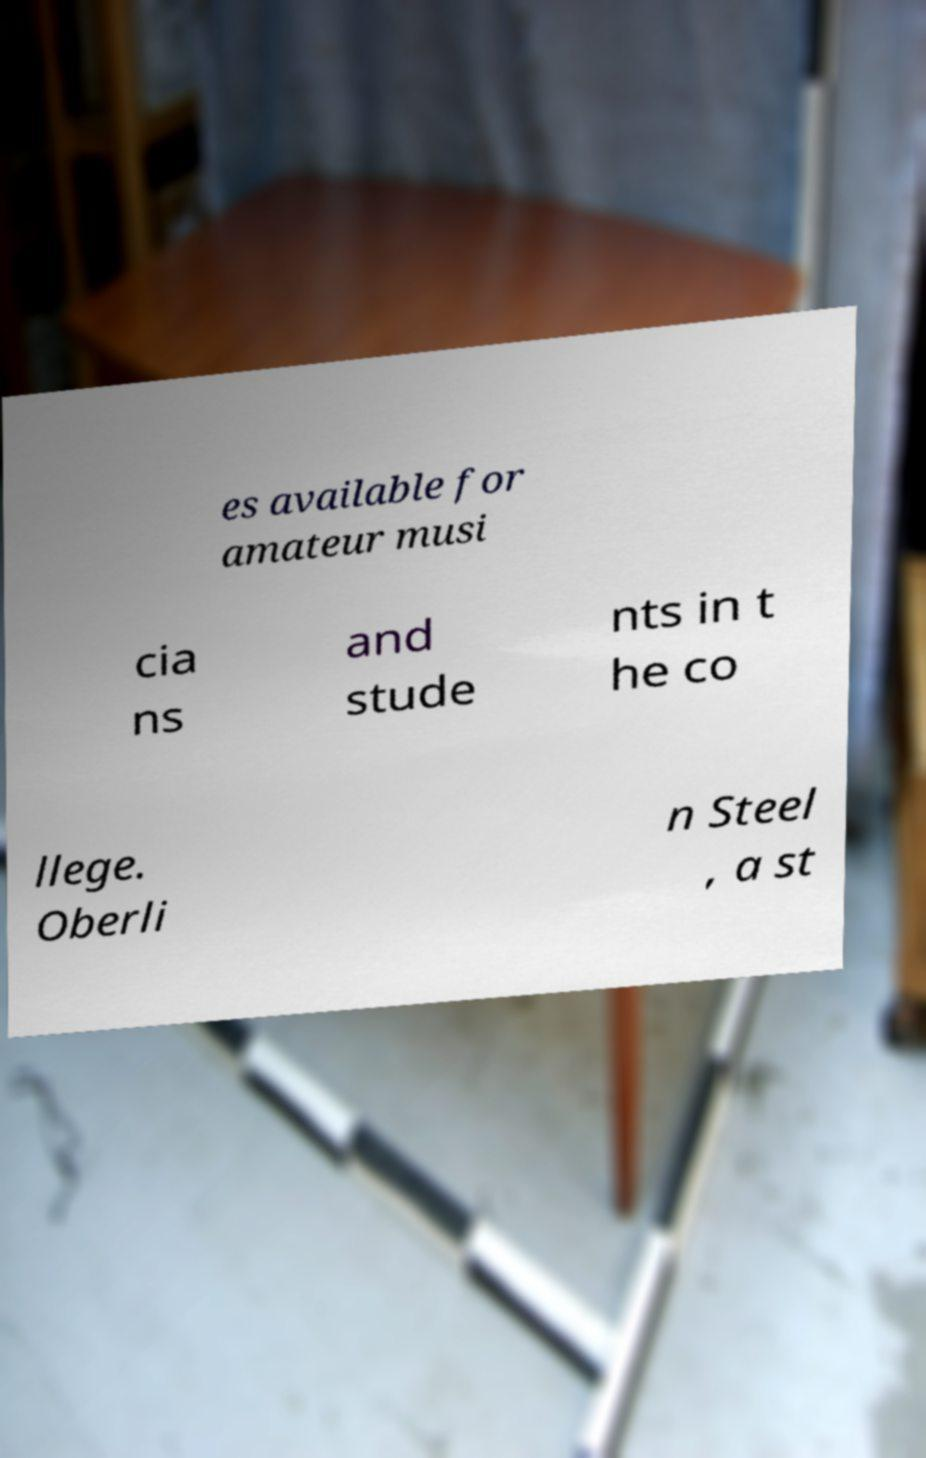Please read and relay the text visible in this image. What does it say? es available for amateur musi cia ns and stude nts in t he co llege. Oberli n Steel , a st 